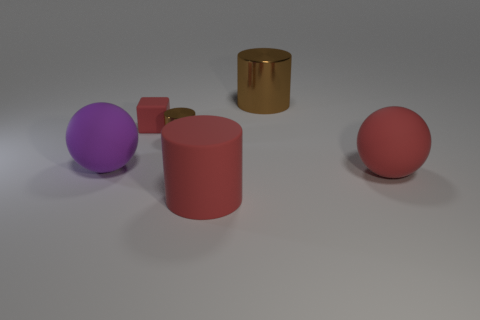Is the large shiny cylinder the same color as the small metal cylinder?
Your answer should be very brief. Yes. Is the color of the tiny object that is to the left of the small cylinder the same as the large rubber cylinder?
Give a very brief answer. Yes. What shape is the small shiny object that is the same color as the big shiny object?
Your response must be concise. Cylinder. There is a cylinder that is the same color as the small rubber block; what is its size?
Provide a succinct answer. Large. There is a red cylinder; how many cylinders are behind it?
Provide a short and direct response. 2. What is the size of the red thing behind the ball right of the brown metallic cylinder behind the cube?
Offer a very short reply. Small. Are there any large brown cylinders in front of the red thing behind the sphere on the left side of the big metal object?
Make the answer very short. No. Are there more matte spheres than large brown metallic cylinders?
Ensure brevity in your answer.  Yes. What is the color of the large matte sphere that is in front of the purple object?
Keep it short and to the point. Red. Are there more matte balls that are to the right of the big brown cylinder than small yellow metallic cubes?
Keep it short and to the point. Yes. 